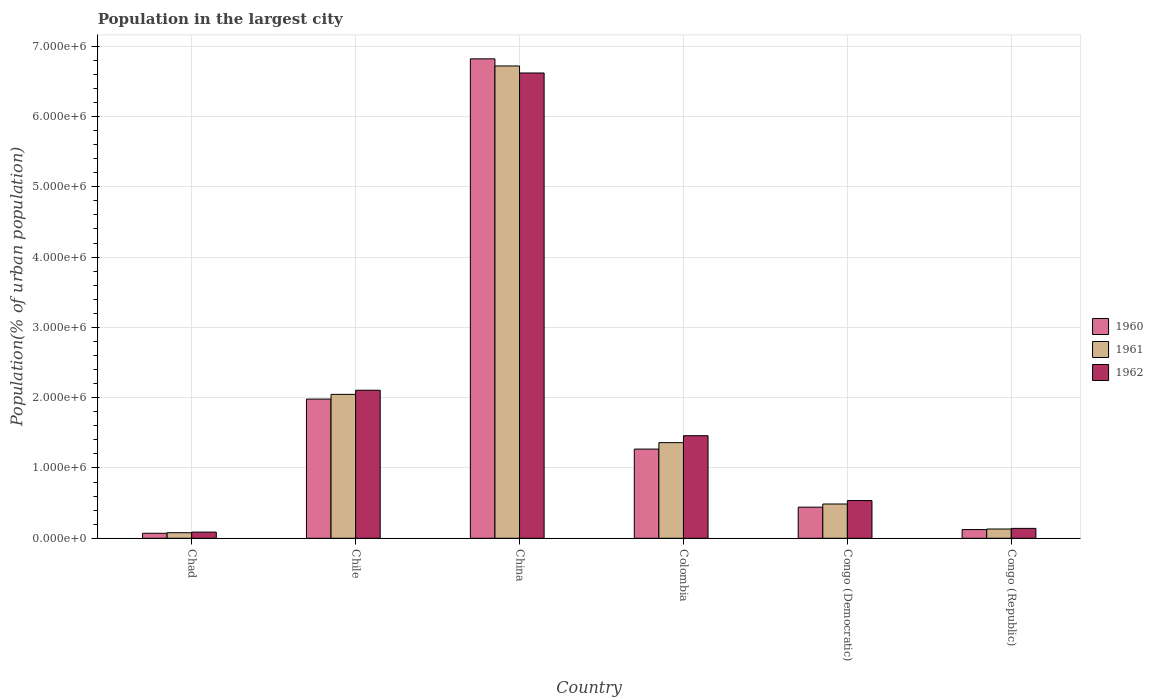How many groups of bars are there?
Keep it short and to the point. 6. Are the number of bars per tick equal to the number of legend labels?
Give a very brief answer. Yes. Are the number of bars on each tick of the X-axis equal?
Offer a very short reply. Yes. How many bars are there on the 1st tick from the right?
Ensure brevity in your answer.  3. In how many cases, is the number of bars for a given country not equal to the number of legend labels?
Offer a very short reply. 0. What is the population in the largest city in 1960 in Colombia?
Ensure brevity in your answer.  1.27e+06. Across all countries, what is the maximum population in the largest city in 1961?
Ensure brevity in your answer.  6.72e+06. Across all countries, what is the minimum population in the largest city in 1960?
Offer a very short reply. 7.13e+04. In which country was the population in the largest city in 1961 maximum?
Your response must be concise. China. In which country was the population in the largest city in 1962 minimum?
Make the answer very short. Chad. What is the total population in the largest city in 1962 in the graph?
Your response must be concise. 1.09e+07. What is the difference between the population in the largest city in 1960 in Chile and that in Congo (Democratic)?
Make the answer very short. 1.54e+06. What is the difference between the population in the largest city in 1960 in China and the population in the largest city in 1961 in Congo (Democratic)?
Provide a short and direct response. 6.33e+06. What is the average population in the largest city in 1962 per country?
Ensure brevity in your answer.  1.82e+06. What is the difference between the population in the largest city of/in 1962 and population in the largest city of/in 1961 in Congo (Democratic)?
Make the answer very short. 4.93e+04. What is the ratio of the population in the largest city in 1960 in Chile to that in Congo (Democratic)?
Provide a succinct answer. 4.47. Is the difference between the population in the largest city in 1962 in Chad and Colombia greater than the difference between the population in the largest city in 1961 in Chad and Colombia?
Offer a terse response. No. What is the difference between the highest and the second highest population in the largest city in 1962?
Provide a succinct answer. 6.47e+05. What is the difference between the highest and the lowest population in the largest city in 1962?
Offer a terse response. 6.53e+06. What does the 3rd bar from the right in Chile represents?
Provide a succinct answer. 1960. How many countries are there in the graph?
Your answer should be compact. 6. What is the difference between two consecutive major ticks on the Y-axis?
Offer a very short reply. 1.00e+06. Where does the legend appear in the graph?
Provide a succinct answer. Center right. How are the legend labels stacked?
Your response must be concise. Vertical. What is the title of the graph?
Offer a terse response. Population in the largest city. What is the label or title of the Y-axis?
Your answer should be very brief. Population(% of urban population). What is the Population(% of urban population) of 1960 in Chad?
Your response must be concise. 7.13e+04. What is the Population(% of urban population) of 1961 in Chad?
Provide a short and direct response. 7.93e+04. What is the Population(% of urban population) of 1962 in Chad?
Provide a succinct answer. 8.82e+04. What is the Population(% of urban population) in 1960 in Chile?
Provide a short and direct response. 1.98e+06. What is the Population(% of urban population) in 1961 in Chile?
Ensure brevity in your answer.  2.05e+06. What is the Population(% of urban population) of 1962 in Chile?
Ensure brevity in your answer.  2.11e+06. What is the Population(% of urban population) in 1960 in China?
Provide a short and direct response. 6.82e+06. What is the Population(% of urban population) of 1961 in China?
Keep it short and to the point. 6.72e+06. What is the Population(% of urban population) in 1962 in China?
Your response must be concise. 6.62e+06. What is the Population(% of urban population) in 1960 in Colombia?
Keep it short and to the point. 1.27e+06. What is the Population(% of urban population) in 1961 in Colombia?
Offer a very short reply. 1.36e+06. What is the Population(% of urban population) of 1962 in Colombia?
Offer a terse response. 1.46e+06. What is the Population(% of urban population) in 1960 in Congo (Democratic)?
Ensure brevity in your answer.  4.43e+05. What is the Population(% of urban population) in 1961 in Congo (Democratic)?
Your response must be concise. 4.88e+05. What is the Population(% of urban population) of 1962 in Congo (Democratic)?
Your answer should be very brief. 5.37e+05. What is the Population(% of urban population) of 1960 in Congo (Republic)?
Your answer should be very brief. 1.24e+05. What is the Population(% of urban population) in 1961 in Congo (Republic)?
Provide a short and direct response. 1.32e+05. What is the Population(% of urban population) of 1962 in Congo (Republic)?
Your answer should be compact. 1.41e+05. Across all countries, what is the maximum Population(% of urban population) in 1960?
Keep it short and to the point. 6.82e+06. Across all countries, what is the maximum Population(% of urban population) in 1961?
Make the answer very short. 6.72e+06. Across all countries, what is the maximum Population(% of urban population) in 1962?
Ensure brevity in your answer.  6.62e+06. Across all countries, what is the minimum Population(% of urban population) of 1960?
Keep it short and to the point. 7.13e+04. Across all countries, what is the minimum Population(% of urban population) in 1961?
Provide a succinct answer. 7.93e+04. Across all countries, what is the minimum Population(% of urban population) of 1962?
Your response must be concise. 8.82e+04. What is the total Population(% of urban population) of 1960 in the graph?
Your answer should be very brief. 1.07e+07. What is the total Population(% of urban population) in 1961 in the graph?
Your answer should be compact. 1.08e+07. What is the total Population(% of urban population) of 1962 in the graph?
Ensure brevity in your answer.  1.09e+07. What is the difference between the Population(% of urban population) of 1960 in Chad and that in Chile?
Offer a very short reply. -1.91e+06. What is the difference between the Population(% of urban population) of 1961 in Chad and that in Chile?
Give a very brief answer. -1.97e+06. What is the difference between the Population(% of urban population) of 1962 in Chad and that in Chile?
Provide a short and direct response. -2.02e+06. What is the difference between the Population(% of urban population) in 1960 in Chad and that in China?
Your answer should be compact. -6.75e+06. What is the difference between the Population(% of urban population) of 1961 in Chad and that in China?
Offer a very short reply. -6.64e+06. What is the difference between the Population(% of urban population) of 1962 in Chad and that in China?
Make the answer very short. -6.53e+06. What is the difference between the Population(% of urban population) of 1960 in Chad and that in Colombia?
Keep it short and to the point. -1.20e+06. What is the difference between the Population(% of urban population) in 1961 in Chad and that in Colombia?
Provide a short and direct response. -1.28e+06. What is the difference between the Population(% of urban population) of 1962 in Chad and that in Colombia?
Provide a succinct answer. -1.37e+06. What is the difference between the Population(% of urban population) of 1960 in Chad and that in Congo (Democratic)?
Your response must be concise. -3.72e+05. What is the difference between the Population(% of urban population) in 1961 in Chad and that in Congo (Democratic)?
Your answer should be very brief. -4.08e+05. What is the difference between the Population(% of urban population) of 1962 in Chad and that in Congo (Democratic)?
Your answer should be very brief. -4.49e+05. What is the difference between the Population(% of urban population) of 1960 in Chad and that in Congo (Republic)?
Provide a succinct answer. -5.24e+04. What is the difference between the Population(% of urban population) of 1961 in Chad and that in Congo (Republic)?
Provide a succinct answer. -5.26e+04. What is the difference between the Population(% of urban population) of 1962 in Chad and that in Congo (Republic)?
Provide a succinct answer. -5.26e+04. What is the difference between the Population(% of urban population) of 1960 in Chile and that in China?
Keep it short and to the point. -4.84e+06. What is the difference between the Population(% of urban population) of 1961 in Chile and that in China?
Provide a succinct answer. -4.67e+06. What is the difference between the Population(% of urban population) of 1962 in Chile and that in China?
Your answer should be compact. -4.51e+06. What is the difference between the Population(% of urban population) in 1960 in Chile and that in Colombia?
Your response must be concise. 7.11e+05. What is the difference between the Population(% of urban population) of 1961 in Chile and that in Colombia?
Keep it short and to the point. 6.87e+05. What is the difference between the Population(% of urban population) in 1962 in Chile and that in Colombia?
Offer a very short reply. 6.47e+05. What is the difference between the Population(% of urban population) of 1960 in Chile and that in Congo (Democratic)?
Your answer should be compact. 1.54e+06. What is the difference between the Population(% of urban population) of 1961 in Chile and that in Congo (Democratic)?
Offer a terse response. 1.56e+06. What is the difference between the Population(% of urban population) of 1962 in Chile and that in Congo (Democratic)?
Provide a short and direct response. 1.57e+06. What is the difference between the Population(% of urban population) in 1960 in Chile and that in Congo (Republic)?
Your answer should be very brief. 1.86e+06. What is the difference between the Population(% of urban population) in 1961 in Chile and that in Congo (Republic)?
Give a very brief answer. 1.92e+06. What is the difference between the Population(% of urban population) of 1962 in Chile and that in Congo (Republic)?
Provide a short and direct response. 1.97e+06. What is the difference between the Population(% of urban population) in 1960 in China and that in Colombia?
Keep it short and to the point. 5.55e+06. What is the difference between the Population(% of urban population) in 1961 in China and that in Colombia?
Make the answer very short. 5.36e+06. What is the difference between the Population(% of urban population) in 1962 in China and that in Colombia?
Provide a succinct answer. 5.16e+06. What is the difference between the Population(% of urban population) in 1960 in China and that in Congo (Democratic)?
Ensure brevity in your answer.  6.38e+06. What is the difference between the Population(% of urban population) of 1961 in China and that in Congo (Democratic)?
Ensure brevity in your answer.  6.23e+06. What is the difference between the Population(% of urban population) of 1962 in China and that in Congo (Democratic)?
Your answer should be very brief. 6.08e+06. What is the difference between the Population(% of urban population) of 1960 in China and that in Congo (Republic)?
Make the answer very short. 6.70e+06. What is the difference between the Population(% of urban population) of 1961 in China and that in Congo (Republic)?
Make the answer very short. 6.59e+06. What is the difference between the Population(% of urban population) in 1962 in China and that in Congo (Republic)?
Ensure brevity in your answer.  6.48e+06. What is the difference between the Population(% of urban population) of 1960 in Colombia and that in Congo (Democratic)?
Offer a very short reply. 8.26e+05. What is the difference between the Population(% of urban population) in 1961 in Colombia and that in Congo (Democratic)?
Provide a short and direct response. 8.73e+05. What is the difference between the Population(% of urban population) of 1962 in Colombia and that in Congo (Democratic)?
Make the answer very short. 9.22e+05. What is the difference between the Population(% of urban population) of 1960 in Colombia and that in Congo (Republic)?
Ensure brevity in your answer.  1.15e+06. What is the difference between the Population(% of urban population) of 1961 in Colombia and that in Congo (Republic)?
Provide a succinct answer. 1.23e+06. What is the difference between the Population(% of urban population) in 1962 in Colombia and that in Congo (Republic)?
Make the answer very short. 1.32e+06. What is the difference between the Population(% of urban population) of 1960 in Congo (Democratic) and that in Congo (Republic)?
Offer a terse response. 3.19e+05. What is the difference between the Population(% of urban population) of 1961 in Congo (Democratic) and that in Congo (Republic)?
Your response must be concise. 3.56e+05. What is the difference between the Population(% of urban population) of 1962 in Congo (Democratic) and that in Congo (Republic)?
Provide a short and direct response. 3.96e+05. What is the difference between the Population(% of urban population) of 1960 in Chad and the Population(% of urban population) of 1961 in Chile?
Your answer should be very brief. -1.98e+06. What is the difference between the Population(% of urban population) in 1960 in Chad and the Population(% of urban population) in 1962 in Chile?
Make the answer very short. -2.03e+06. What is the difference between the Population(% of urban population) in 1961 in Chad and the Population(% of urban population) in 1962 in Chile?
Provide a short and direct response. -2.03e+06. What is the difference between the Population(% of urban population) in 1960 in Chad and the Population(% of urban population) in 1961 in China?
Offer a very short reply. -6.65e+06. What is the difference between the Population(% of urban population) of 1960 in Chad and the Population(% of urban population) of 1962 in China?
Offer a very short reply. -6.55e+06. What is the difference between the Population(% of urban population) in 1961 in Chad and the Population(% of urban population) in 1962 in China?
Ensure brevity in your answer.  -6.54e+06. What is the difference between the Population(% of urban population) in 1960 in Chad and the Population(% of urban population) in 1961 in Colombia?
Give a very brief answer. -1.29e+06. What is the difference between the Population(% of urban population) of 1960 in Chad and the Population(% of urban population) of 1962 in Colombia?
Offer a terse response. -1.39e+06. What is the difference between the Population(% of urban population) in 1961 in Chad and the Population(% of urban population) in 1962 in Colombia?
Your response must be concise. -1.38e+06. What is the difference between the Population(% of urban population) of 1960 in Chad and the Population(% of urban population) of 1961 in Congo (Democratic)?
Ensure brevity in your answer.  -4.16e+05. What is the difference between the Population(% of urban population) in 1960 in Chad and the Population(% of urban population) in 1962 in Congo (Democratic)?
Your answer should be compact. -4.66e+05. What is the difference between the Population(% of urban population) of 1961 in Chad and the Population(% of urban population) of 1962 in Congo (Democratic)?
Your answer should be very brief. -4.58e+05. What is the difference between the Population(% of urban population) of 1960 in Chad and the Population(% of urban population) of 1961 in Congo (Republic)?
Provide a succinct answer. -6.06e+04. What is the difference between the Population(% of urban population) in 1960 in Chad and the Population(% of urban population) in 1962 in Congo (Republic)?
Ensure brevity in your answer.  -6.95e+04. What is the difference between the Population(% of urban population) in 1961 in Chad and the Population(% of urban population) in 1962 in Congo (Republic)?
Ensure brevity in your answer.  -6.15e+04. What is the difference between the Population(% of urban population) in 1960 in Chile and the Population(% of urban population) in 1961 in China?
Offer a very short reply. -4.74e+06. What is the difference between the Population(% of urban population) in 1960 in Chile and the Population(% of urban population) in 1962 in China?
Offer a very short reply. -4.64e+06. What is the difference between the Population(% of urban population) of 1961 in Chile and the Population(% of urban population) of 1962 in China?
Ensure brevity in your answer.  -4.57e+06. What is the difference between the Population(% of urban population) of 1960 in Chile and the Population(% of urban population) of 1961 in Colombia?
Provide a succinct answer. 6.20e+05. What is the difference between the Population(% of urban population) of 1960 in Chile and the Population(% of urban population) of 1962 in Colombia?
Offer a terse response. 5.21e+05. What is the difference between the Population(% of urban population) of 1961 in Chile and the Population(% of urban population) of 1962 in Colombia?
Keep it short and to the point. 5.88e+05. What is the difference between the Population(% of urban population) of 1960 in Chile and the Population(% of urban population) of 1961 in Congo (Democratic)?
Your response must be concise. 1.49e+06. What is the difference between the Population(% of urban population) in 1960 in Chile and the Population(% of urban population) in 1962 in Congo (Democratic)?
Your answer should be compact. 1.44e+06. What is the difference between the Population(% of urban population) of 1961 in Chile and the Population(% of urban population) of 1962 in Congo (Democratic)?
Offer a terse response. 1.51e+06. What is the difference between the Population(% of urban population) in 1960 in Chile and the Population(% of urban population) in 1961 in Congo (Republic)?
Provide a short and direct response. 1.85e+06. What is the difference between the Population(% of urban population) of 1960 in Chile and the Population(% of urban population) of 1962 in Congo (Republic)?
Provide a succinct answer. 1.84e+06. What is the difference between the Population(% of urban population) of 1961 in Chile and the Population(% of urban population) of 1962 in Congo (Republic)?
Your answer should be compact. 1.91e+06. What is the difference between the Population(% of urban population) of 1960 in China and the Population(% of urban population) of 1961 in Colombia?
Your answer should be very brief. 5.46e+06. What is the difference between the Population(% of urban population) in 1960 in China and the Population(% of urban population) in 1962 in Colombia?
Your answer should be compact. 5.36e+06. What is the difference between the Population(% of urban population) in 1961 in China and the Population(% of urban population) in 1962 in Colombia?
Provide a short and direct response. 5.26e+06. What is the difference between the Population(% of urban population) of 1960 in China and the Population(% of urban population) of 1961 in Congo (Democratic)?
Ensure brevity in your answer.  6.33e+06. What is the difference between the Population(% of urban population) in 1960 in China and the Population(% of urban population) in 1962 in Congo (Democratic)?
Your answer should be very brief. 6.28e+06. What is the difference between the Population(% of urban population) of 1961 in China and the Population(% of urban population) of 1962 in Congo (Democratic)?
Make the answer very short. 6.18e+06. What is the difference between the Population(% of urban population) in 1960 in China and the Population(% of urban population) in 1961 in Congo (Republic)?
Offer a terse response. 6.69e+06. What is the difference between the Population(% of urban population) of 1960 in China and the Population(% of urban population) of 1962 in Congo (Republic)?
Give a very brief answer. 6.68e+06. What is the difference between the Population(% of urban population) in 1961 in China and the Population(% of urban population) in 1962 in Congo (Republic)?
Give a very brief answer. 6.58e+06. What is the difference between the Population(% of urban population) in 1960 in Colombia and the Population(% of urban population) in 1961 in Congo (Democratic)?
Make the answer very short. 7.81e+05. What is the difference between the Population(% of urban population) in 1960 in Colombia and the Population(% of urban population) in 1962 in Congo (Democratic)?
Your answer should be very brief. 7.32e+05. What is the difference between the Population(% of urban population) of 1961 in Colombia and the Population(% of urban population) of 1962 in Congo (Democratic)?
Offer a very short reply. 8.23e+05. What is the difference between the Population(% of urban population) of 1960 in Colombia and the Population(% of urban population) of 1961 in Congo (Republic)?
Give a very brief answer. 1.14e+06. What is the difference between the Population(% of urban population) in 1960 in Colombia and the Population(% of urban population) in 1962 in Congo (Republic)?
Make the answer very short. 1.13e+06. What is the difference between the Population(% of urban population) in 1961 in Colombia and the Population(% of urban population) in 1962 in Congo (Republic)?
Provide a short and direct response. 1.22e+06. What is the difference between the Population(% of urban population) in 1960 in Congo (Democratic) and the Population(% of urban population) in 1961 in Congo (Republic)?
Keep it short and to the point. 3.11e+05. What is the difference between the Population(% of urban population) in 1960 in Congo (Democratic) and the Population(% of urban population) in 1962 in Congo (Republic)?
Provide a succinct answer. 3.02e+05. What is the difference between the Population(% of urban population) in 1961 in Congo (Democratic) and the Population(% of urban population) in 1962 in Congo (Republic)?
Give a very brief answer. 3.47e+05. What is the average Population(% of urban population) in 1960 per country?
Your answer should be compact. 1.78e+06. What is the average Population(% of urban population) of 1961 per country?
Offer a very short reply. 1.80e+06. What is the average Population(% of urban population) in 1962 per country?
Ensure brevity in your answer.  1.82e+06. What is the difference between the Population(% of urban population) of 1960 and Population(% of urban population) of 1961 in Chad?
Keep it short and to the point. -7987. What is the difference between the Population(% of urban population) in 1960 and Population(% of urban population) in 1962 in Chad?
Your answer should be compact. -1.69e+04. What is the difference between the Population(% of urban population) of 1961 and Population(% of urban population) of 1962 in Chad?
Offer a terse response. -8895. What is the difference between the Population(% of urban population) of 1960 and Population(% of urban population) of 1961 in Chile?
Your answer should be very brief. -6.71e+04. What is the difference between the Population(% of urban population) of 1960 and Population(% of urban population) of 1962 in Chile?
Offer a very short reply. -1.26e+05. What is the difference between the Population(% of urban population) in 1961 and Population(% of urban population) in 1962 in Chile?
Provide a succinct answer. -5.90e+04. What is the difference between the Population(% of urban population) of 1960 and Population(% of urban population) of 1961 in China?
Keep it short and to the point. 1.01e+05. What is the difference between the Population(% of urban population) in 1960 and Population(% of urban population) in 1962 in China?
Provide a short and direct response. 2.01e+05. What is the difference between the Population(% of urban population) of 1961 and Population(% of urban population) of 1962 in China?
Provide a succinct answer. 9.99e+04. What is the difference between the Population(% of urban population) of 1960 and Population(% of urban population) of 1961 in Colombia?
Provide a short and direct response. -9.18e+04. What is the difference between the Population(% of urban population) of 1960 and Population(% of urban population) of 1962 in Colombia?
Offer a terse response. -1.90e+05. What is the difference between the Population(% of urban population) of 1961 and Population(% of urban population) of 1962 in Colombia?
Offer a terse response. -9.86e+04. What is the difference between the Population(% of urban population) of 1960 and Population(% of urban population) of 1961 in Congo (Democratic)?
Make the answer very short. -4.48e+04. What is the difference between the Population(% of urban population) in 1960 and Population(% of urban population) in 1962 in Congo (Democratic)?
Your response must be concise. -9.41e+04. What is the difference between the Population(% of urban population) of 1961 and Population(% of urban population) of 1962 in Congo (Democratic)?
Offer a very short reply. -4.93e+04. What is the difference between the Population(% of urban population) of 1960 and Population(% of urban population) of 1961 in Congo (Republic)?
Offer a terse response. -8224. What is the difference between the Population(% of urban population) in 1960 and Population(% of urban population) in 1962 in Congo (Republic)?
Your answer should be very brief. -1.71e+04. What is the difference between the Population(% of urban population) of 1961 and Population(% of urban population) of 1962 in Congo (Republic)?
Give a very brief answer. -8884. What is the ratio of the Population(% of urban population) of 1960 in Chad to that in Chile?
Give a very brief answer. 0.04. What is the ratio of the Population(% of urban population) of 1961 in Chad to that in Chile?
Offer a very short reply. 0.04. What is the ratio of the Population(% of urban population) of 1962 in Chad to that in Chile?
Your response must be concise. 0.04. What is the ratio of the Population(% of urban population) of 1960 in Chad to that in China?
Provide a short and direct response. 0.01. What is the ratio of the Population(% of urban population) in 1961 in Chad to that in China?
Offer a terse response. 0.01. What is the ratio of the Population(% of urban population) of 1962 in Chad to that in China?
Offer a very short reply. 0.01. What is the ratio of the Population(% of urban population) of 1960 in Chad to that in Colombia?
Your response must be concise. 0.06. What is the ratio of the Population(% of urban population) in 1961 in Chad to that in Colombia?
Make the answer very short. 0.06. What is the ratio of the Population(% of urban population) of 1962 in Chad to that in Colombia?
Your response must be concise. 0.06. What is the ratio of the Population(% of urban population) in 1960 in Chad to that in Congo (Democratic)?
Your response must be concise. 0.16. What is the ratio of the Population(% of urban population) in 1961 in Chad to that in Congo (Democratic)?
Offer a terse response. 0.16. What is the ratio of the Population(% of urban population) of 1962 in Chad to that in Congo (Democratic)?
Provide a short and direct response. 0.16. What is the ratio of the Population(% of urban population) of 1960 in Chad to that in Congo (Republic)?
Your answer should be very brief. 0.58. What is the ratio of the Population(% of urban population) in 1961 in Chad to that in Congo (Republic)?
Provide a succinct answer. 0.6. What is the ratio of the Population(% of urban population) of 1962 in Chad to that in Congo (Republic)?
Offer a very short reply. 0.63. What is the ratio of the Population(% of urban population) of 1960 in Chile to that in China?
Provide a succinct answer. 0.29. What is the ratio of the Population(% of urban population) of 1961 in Chile to that in China?
Offer a terse response. 0.3. What is the ratio of the Population(% of urban population) of 1962 in Chile to that in China?
Keep it short and to the point. 0.32. What is the ratio of the Population(% of urban population) of 1960 in Chile to that in Colombia?
Your answer should be very brief. 1.56. What is the ratio of the Population(% of urban population) in 1961 in Chile to that in Colombia?
Give a very brief answer. 1.5. What is the ratio of the Population(% of urban population) of 1962 in Chile to that in Colombia?
Make the answer very short. 1.44. What is the ratio of the Population(% of urban population) of 1960 in Chile to that in Congo (Democratic)?
Provide a short and direct response. 4.47. What is the ratio of the Population(% of urban population) of 1961 in Chile to that in Congo (Democratic)?
Offer a terse response. 4.2. What is the ratio of the Population(% of urban population) of 1962 in Chile to that in Congo (Democratic)?
Provide a succinct answer. 3.92. What is the ratio of the Population(% of urban population) in 1960 in Chile to that in Congo (Republic)?
Provide a short and direct response. 16.01. What is the ratio of the Population(% of urban population) of 1961 in Chile to that in Congo (Republic)?
Give a very brief answer. 15.52. What is the ratio of the Population(% of urban population) in 1962 in Chile to that in Congo (Republic)?
Your answer should be very brief. 14.96. What is the ratio of the Population(% of urban population) in 1960 in China to that in Colombia?
Your answer should be compact. 5.38. What is the ratio of the Population(% of urban population) of 1961 in China to that in Colombia?
Keep it short and to the point. 4.94. What is the ratio of the Population(% of urban population) of 1962 in China to that in Colombia?
Offer a terse response. 4.54. What is the ratio of the Population(% of urban population) of 1960 in China to that in Congo (Democratic)?
Your answer should be very brief. 15.4. What is the ratio of the Population(% of urban population) of 1961 in China to that in Congo (Democratic)?
Your answer should be very brief. 13.78. What is the ratio of the Population(% of urban population) in 1962 in China to that in Congo (Democratic)?
Make the answer very short. 12.33. What is the ratio of the Population(% of urban population) in 1960 in China to that in Congo (Republic)?
Keep it short and to the point. 55.16. What is the ratio of the Population(% of urban population) in 1961 in China to that in Congo (Republic)?
Keep it short and to the point. 50.95. What is the ratio of the Population(% of urban population) in 1962 in China to that in Congo (Republic)?
Keep it short and to the point. 47.02. What is the ratio of the Population(% of urban population) in 1960 in Colombia to that in Congo (Democratic)?
Make the answer very short. 2.86. What is the ratio of the Population(% of urban population) of 1961 in Colombia to that in Congo (Democratic)?
Give a very brief answer. 2.79. What is the ratio of the Population(% of urban population) in 1962 in Colombia to that in Congo (Democratic)?
Provide a short and direct response. 2.72. What is the ratio of the Population(% of urban population) in 1960 in Colombia to that in Congo (Republic)?
Your response must be concise. 10.26. What is the ratio of the Population(% of urban population) of 1961 in Colombia to that in Congo (Republic)?
Offer a terse response. 10.32. What is the ratio of the Population(% of urban population) in 1962 in Colombia to that in Congo (Republic)?
Your response must be concise. 10.37. What is the ratio of the Population(% of urban population) in 1960 in Congo (Democratic) to that in Congo (Republic)?
Your response must be concise. 3.58. What is the ratio of the Population(% of urban population) of 1961 in Congo (Democratic) to that in Congo (Republic)?
Provide a succinct answer. 3.7. What is the ratio of the Population(% of urban population) in 1962 in Congo (Democratic) to that in Congo (Republic)?
Provide a succinct answer. 3.81. What is the difference between the highest and the second highest Population(% of urban population) in 1960?
Your response must be concise. 4.84e+06. What is the difference between the highest and the second highest Population(% of urban population) in 1961?
Your answer should be very brief. 4.67e+06. What is the difference between the highest and the second highest Population(% of urban population) in 1962?
Provide a short and direct response. 4.51e+06. What is the difference between the highest and the lowest Population(% of urban population) of 1960?
Your response must be concise. 6.75e+06. What is the difference between the highest and the lowest Population(% of urban population) in 1961?
Keep it short and to the point. 6.64e+06. What is the difference between the highest and the lowest Population(% of urban population) of 1962?
Keep it short and to the point. 6.53e+06. 